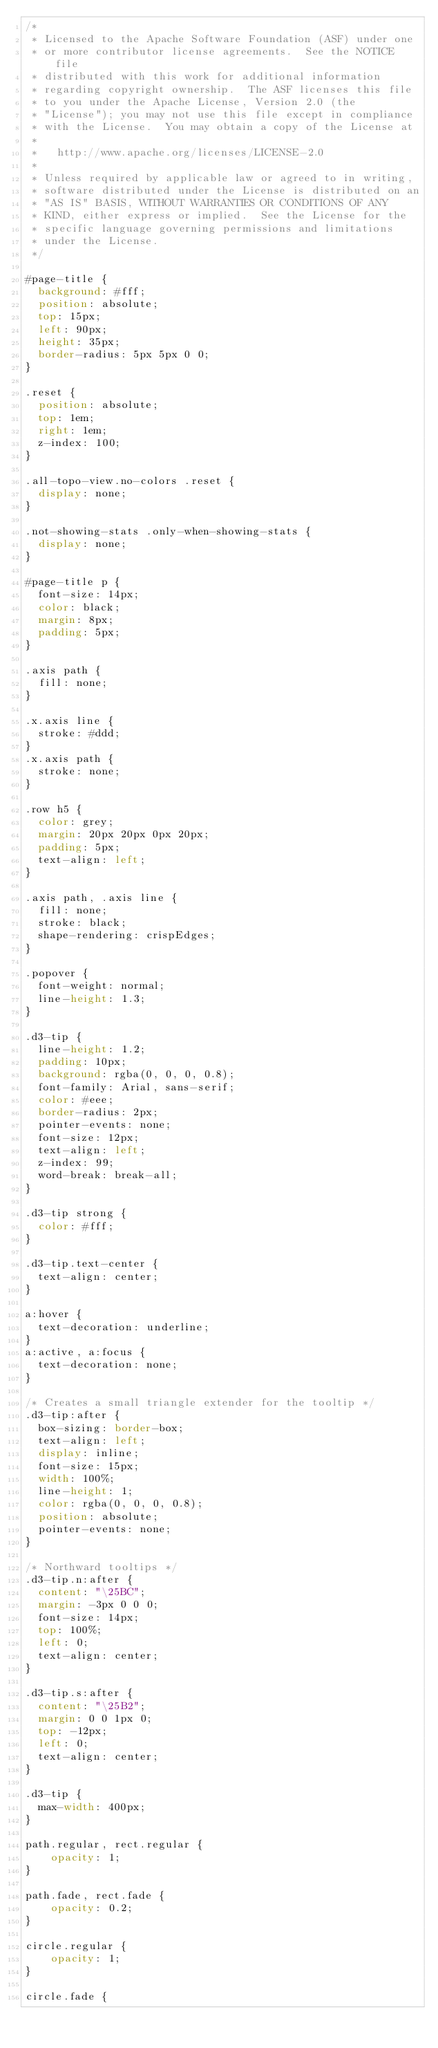Convert code to text. <code><loc_0><loc_0><loc_500><loc_500><_CSS_>/*
 * Licensed to the Apache Software Foundation (ASF) under one
 * or more contributor license agreements.  See the NOTICE file
 * distributed with this work for additional information
 * regarding copyright ownership.  The ASF licenses this file
 * to you under the Apache License, Version 2.0 (the
 * "License"); you may not use this file except in compliance
 * with the License.  You may obtain a copy of the License at
 * 
 *   http://www.apache.org/licenses/LICENSE-2.0
 * 
 * Unless required by applicable law or agreed to in writing,
 * software distributed under the License is distributed on an
 * "AS IS" BASIS, WITHOUT WARRANTIES OR CONDITIONS OF ANY
 * KIND, either express or implied.  See the License for the
 * specific language governing permissions and limitations
 * under the License.
 */

#page-title {
  background: #fff;
  position: absolute;
  top: 15px;
  left: 90px;
  height: 35px;
  border-radius: 5px 5px 0 0;
}

.reset {
  position: absolute;
  top: 1em;
  right: 1em;
  z-index: 100;
}

.all-topo-view.no-colors .reset {
  display: none;
}

.not-showing-stats .only-when-showing-stats {
  display: none;
}

#page-title p {
  font-size: 14px;
  color: black;
  margin: 8px;
  padding: 5px;
}

.axis path {
  fill: none;
}

.x.axis line {
  stroke: #ddd;
}
.x.axis path {
  stroke: none;
}

.row h5 {
  color: grey;
  margin: 20px 20px 0px 20px;
  padding: 5px;
  text-align: left;
}

.axis path, .axis line {
  fill: none;
  stroke: black;
  shape-rendering: crispEdges;
}

.popover {
  font-weight: normal;
  line-height: 1.3;
}

.d3-tip {
  line-height: 1.2;
  padding: 10px;
  background: rgba(0, 0, 0, 0.8);
  font-family: Arial, sans-serif;
  color: #eee;
  border-radius: 2px;
  pointer-events: none;
  font-size: 12px;
  text-align: left;
  z-index: 99;
  word-break: break-all;
}

.d3-tip strong {
  color: #fff;
}

.d3-tip.text-center {
  text-align: center;
}

a:hover {
  text-decoration: underline;
}
a:active, a:focus {
  text-decoration: none;
}

/* Creates a small triangle extender for the tooltip */
.d3-tip:after {
  box-sizing: border-box;
  text-align: left;
  display: inline;
  font-size: 15px;
  width: 100%;
  line-height: 1;
  color: rgba(0, 0, 0, 0.8);
  position: absolute;
  pointer-events: none;
}

/* Northward tooltips */
.d3-tip.n:after {
  content: "\25BC";
  margin: -3px 0 0 0;
  font-size: 14px;
  top: 100%;
  left: 0;
  text-align: center;
}

.d3-tip.s:after {
  content: "\25B2";
  margin: 0 0 1px 0;
  top: -12px;
  left: 0;
  text-align: center;
}

.d3-tip {
  max-width: 400px;
}

path.regular, rect.regular {
    opacity: 1;
}

path.fade, rect.fade {
    opacity: 0.2;
}

circle.regular {
    opacity: 1;
}

circle.fade {</code> 